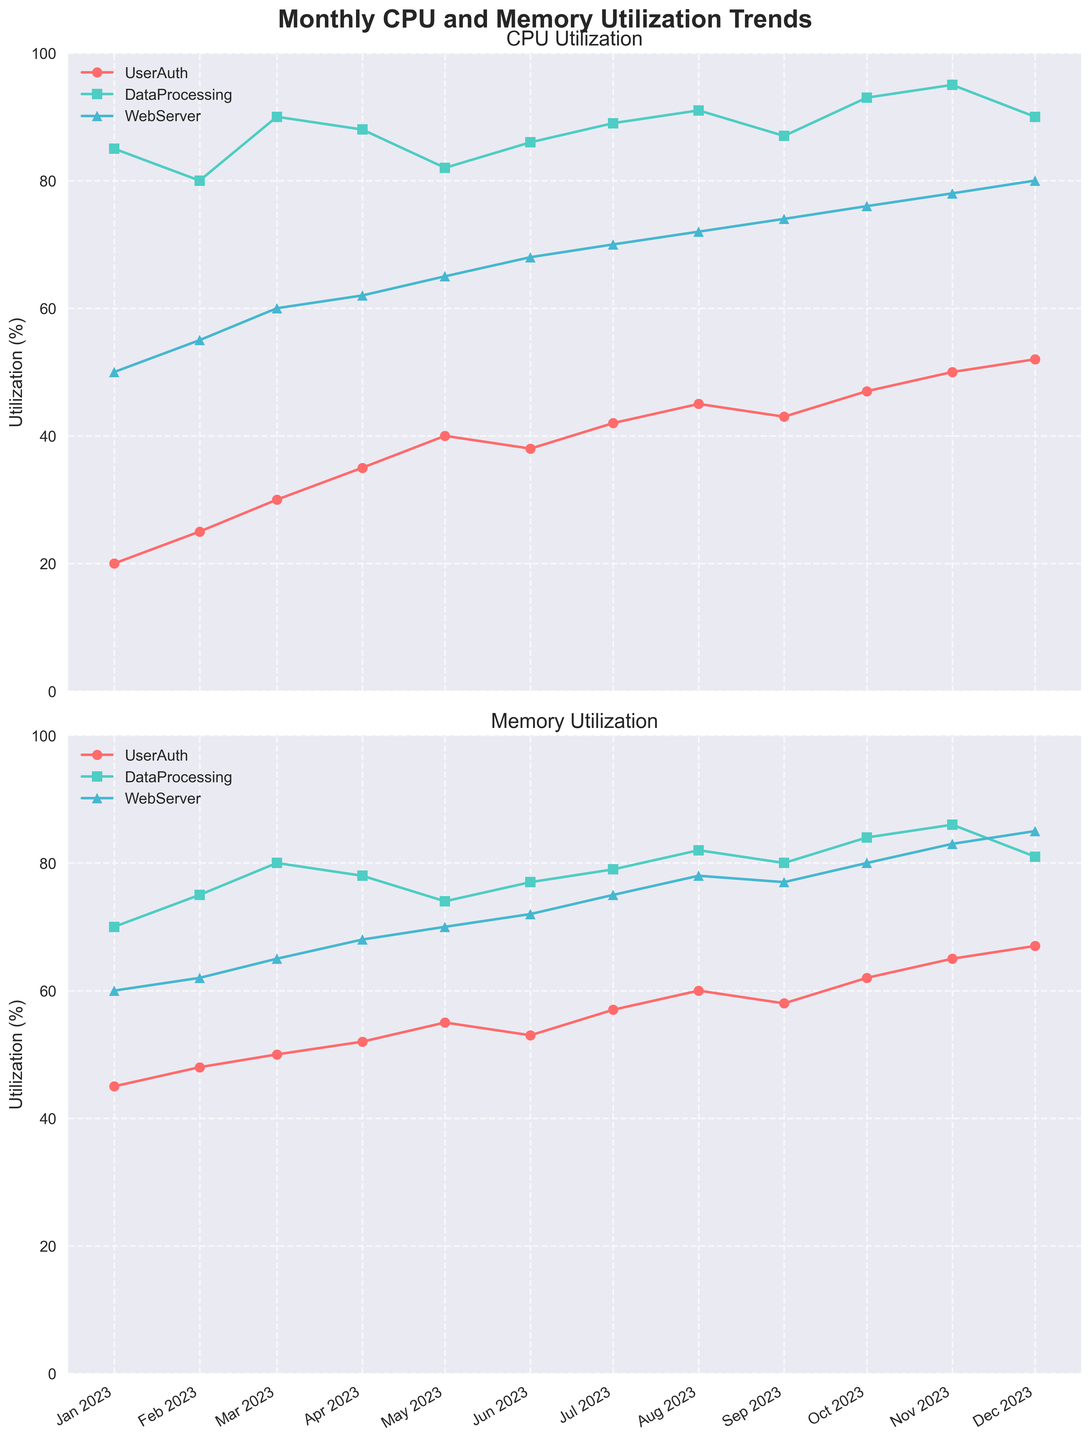What is the title of the figure? The title is located at the top of the figure, typically in a larger and bolder font. It summarizes the main topic of the plot. By looking at the top of the figure, you can see the title "Monthly CPU and Memory Utilization Trends".
Answer: Monthly CPU and Memory Utilization Trends Which service had the highest CPU utilization in December 2023? To find this, look at the CPU utilization plot (upper subplot) for December 2023. Compare the values of different services on that date. The DataProcessing service has the highest CPU utilization of 90%.
Answer: DataProcessing What was the CPU utilization trend for the WebServer service throughout the year? To identify the trend, look at the WebServer service's line in the CPU utilization plot (upper subplot). Notice the direction and steepness of the line from January to December 2023. The trend shows a generally increasing CPU utilization from 50% in January to 80% in December.
Answer: Increasing Which month shows the maximum memory utilization for the UserAuth service? To find the month with the maximum memory utilization for UserAuth, look at the memory utilization plot (lower subplot) and identify the highest point on the UserAuth service's line. The highest memory utilization for UserAuth is in December 2023 at 67%.
Answer: December Compare the CPU utilization of UserAuth and DataProcessing for July 2023. Which is higher and by how much? Look at the CPU utilization values for both UserAuth and DataProcessing on the CPU utilization plot for July 2023. UserAuth's utilization is 42%, and DataProcessing's is 89%. Subtract the UserAuth value from the DataProcessing value (89 - 42 = 47).
Answer: DataProcessing by 47% How does the memory utilization of WebServer change from January to June 2023? To observe the change, look at the memory utilization plot from January to June for WebServer. Note the values in January (60%) and June (72%). The change is an increase by 12 percentage points.
Answer: Increases by 12% What is the difference in CPU utilization between WebServer and DataProcessing in November 2023? Look at the CPU utilization values for both WebServer and DataProcessing on the CPU utilization plot for November 2023. Subtract the WebServer value from the DataProcessing value (95 - 78 = 17).
Answer: 17% Which service consistently shows the highest memory utilization throughout the year? Observe the memory utilization plot across all months and identify the service that consistently has the highest values. DataProcessing consistently has the highest memory utilization.
Answer: DataProcessing Between February and May 2023, how much did the CPU utilization for UserAuth increase? Find the values for CPU utilization of UserAuth in February (25%) and May (40%), and subtract the February value from the May value (40 - 25 = 15).
Answer: 15% In October 2023, which service has the closest CPU utilization percentage to 50%? Look at the CPU utilization plot for October 2023 and note the values for each service. The closest to 50% is UserAuth at 47%.
Answer: UserAuth 